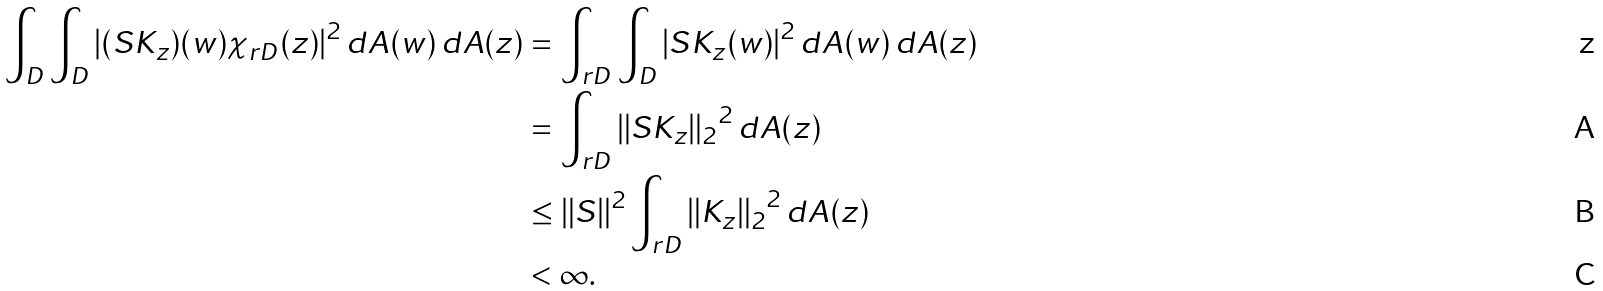<formula> <loc_0><loc_0><loc_500><loc_500>\int _ { D } \int _ { D } | ( S K _ { z } ) ( w ) \chi _ { r D } ( z ) | ^ { 2 } \, d A ( w ) \, d A ( z ) & = \int _ { r D } \int _ { D } | S K _ { z } ( w ) | ^ { 2 } \, d A ( w ) \, d A ( z ) \\ & = \int _ { r D } { \| S K _ { z } \| _ { 2 } } ^ { 2 } \, d A ( z ) \\ & \leq \| S \| ^ { 2 } \int _ { r D } { \| K _ { z } \| _ { 2 } } ^ { 2 } \, d A ( z ) \\ & < \infty .</formula> 